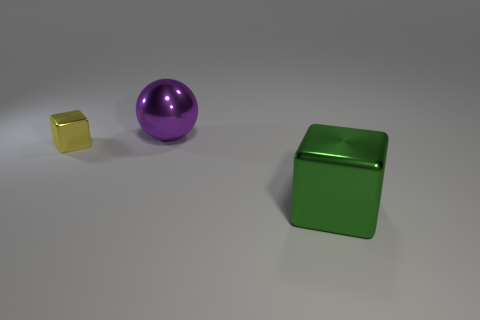Add 3 tiny yellow metallic blocks. How many objects exist? 6 Subtract all blocks. How many objects are left? 1 Add 3 big purple balls. How many big purple balls are left? 4 Add 3 yellow blocks. How many yellow blocks exist? 4 Subtract 0 cyan cylinders. How many objects are left? 3 Subtract all small gray cubes. Subtract all big blocks. How many objects are left? 2 